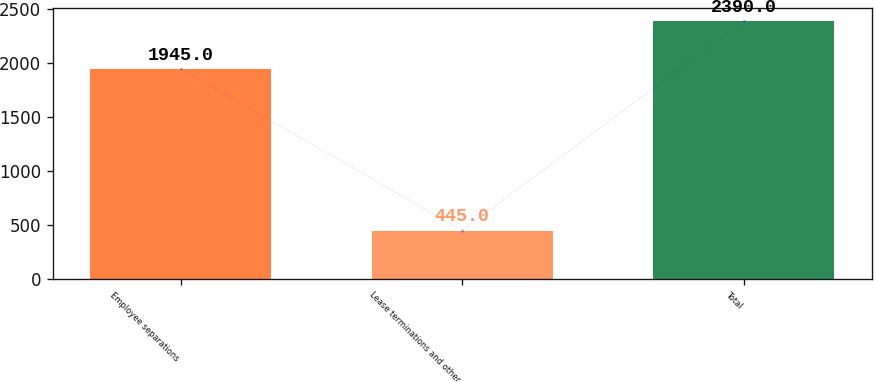Convert chart to OTSL. <chart><loc_0><loc_0><loc_500><loc_500><bar_chart><fcel>Employee separations<fcel>Lease terminations and other<fcel>Total<nl><fcel>1945<fcel>445<fcel>2390<nl></chart> 